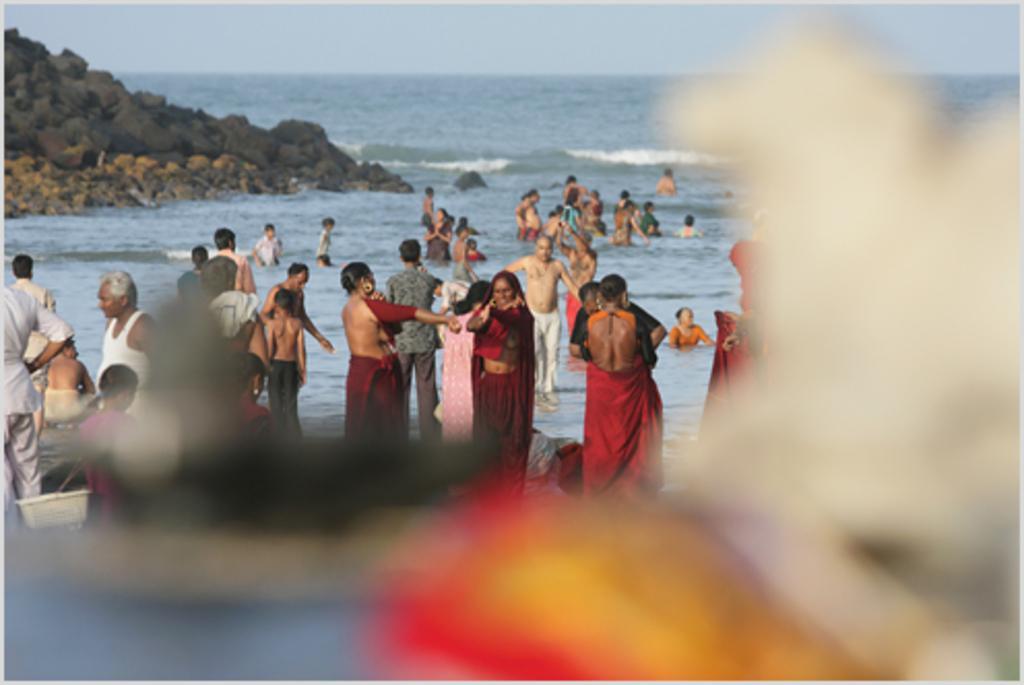Could you give a brief overview of what you see in this image? There are many people. Some are in the water. On the left side there are rocks. In the background there is water and sky. Some part of the image is blurred. 